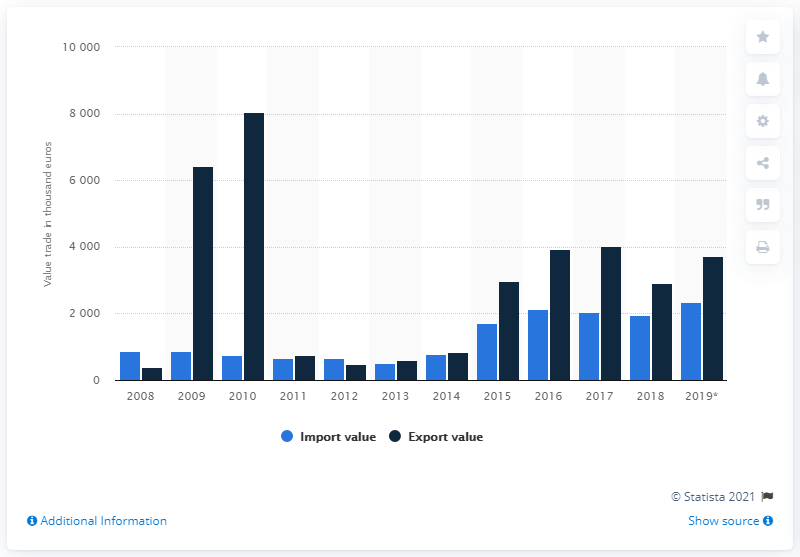Indicate a few pertinent items in this graphic. The export value of saffron in 2019 was 3,709. 